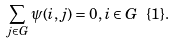Convert formula to latex. <formula><loc_0><loc_0><loc_500><loc_500>\sum _ { j \in G } \psi ( i , j ) = 0 , i \in G \ \{ 1 \} .</formula> 